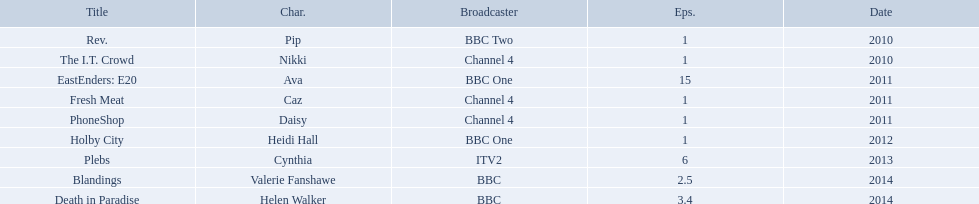Which characters were featured in more then one episode? Ava, Cynthia, Valerie Fanshawe, Helen Walker. Which of these were not in 2014? Ava, Cynthia. Write the full table. {'header': ['Title', 'Char.', 'Broadcaster', 'Eps.', 'Date'], 'rows': [['Rev.', 'Pip', 'BBC Two', '1', '2010'], ['The I.T. Crowd', 'Nikki', 'Channel 4', '1', '2010'], ['EastEnders: E20', 'Ava', 'BBC One', '15', '2011'], ['Fresh Meat', 'Caz', 'Channel 4', '1', '2011'], ['PhoneShop', 'Daisy', 'Channel 4', '1', '2011'], ['Holby City', 'Heidi Hall', 'BBC One', '1', '2012'], ['Plebs', 'Cynthia', 'ITV2', '6', '2013'], ['Blandings', 'Valerie Fanshawe', 'BBC', '2.5', '2014'], ['Death in Paradise', 'Helen Walker', 'BBC', '3.4', '2014']]} Which one of those was not on a bbc broadcaster? Cynthia. 